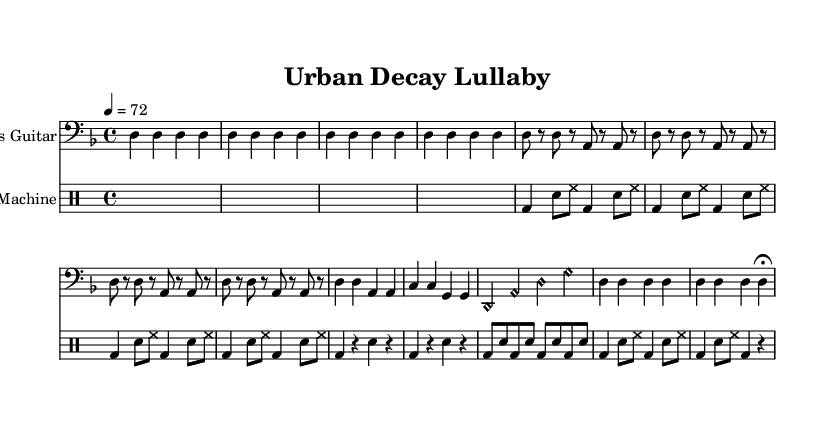What is the key signature of this music? The key signature is indicated at the beginning of the piece, showing two flats. The single flat in the staff denotes B flat, while the back flat denotes E flat. This tells us the piece is in D minor.
Answer: D minor What is the time signature of this piece? The time signature is located at the start of the score, shown as a fraction 4/4. This means there are four beats in each measure, and a quarter note gets one beat.
Answer: 4/4 What is the tempo marking for this composition? The tempo marking is indicated in the score, showing "4 = 72." This means that the quarter note should be played at a speed of 72 beats per minute.
Answer: 72 How many measures are in the Intro section for the bass guitar? The Intro section consists of four measures, as indicated by the repeated notation. Each measure is filled with the note D on the bass staff.
Answer: 4 What type of bass notes are used in the Bridge section? In the Bridge section, harmonic notes are played on the bass guitar. These notes are indicated by the notation "<d harmonic>", which denotes that the player should utilize harmonics for a distinct sound.
Answer: Harmonic What is the rhythmic pattern primarily used in the Verse section? The rhythmic pattern in the Verse section breaks down into alternating notes and rests, specifically using eighth notes and quarter notes. This pattern creates a laid-back yet engaging groove typical of lo-fi.
Answer: Eighth and quarter notes How does the song transition from the Chorus to the Outro? The transition occurs as the Chorus ends on a pair of played quarter notes and moves directly back into the Outro section, resembling a call-and-response structure common in punk music. The consistent bass line helps maintain the continuity.
Answer: Transition through direct repetition 